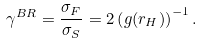Convert formula to latex. <formula><loc_0><loc_0><loc_500><loc_500>\gamma ^ { B R } = \frac { \sigma _ { F } } { \sigma _ { S } } = 2 \left ( g ( r _ { H } ) \right ) ^ { - 1 } .</formula> 